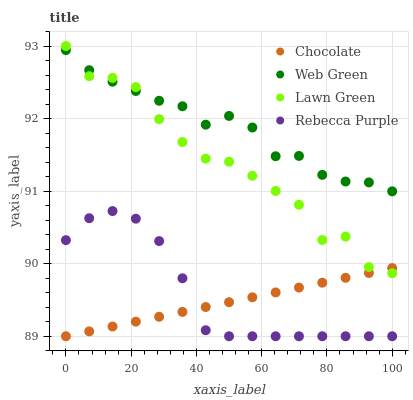Does Chocolate have the minimum area under the curve?
Answer yes or no. Yes. Does Web Green have the maximum area under the curve?
Answer yes or no. Yes. Does Rebecca Purple have the minimum area under the curve?
Answer yes or no. No. Does Rebecca Purple have the maximum area under the curve?
Answer yes or no. No. Is Chocolate the smoothest?
Answer yes or no. Yes. Is Lawn Green the roughest?
Answer yes or no. Yes. Is Rebecca Purple the smoothest?
Answer yes or no. No. Is Rebecca Purple the roughest?
Answer yes or no. No. Does Rebecca Purple have the lowest value?
Answer yes or no. Yes. Does Web Green have the lowest value?
Answer yes or no. No. Does Lawn Green have the highest value?
Answer yes or no. Yes. Does Rebecca Purple have the highest value?
Answer yes or no. No. Is Rebecca Purple less than Lawn Green?
Answer yes or no. Yes. Is Web Green greater than Rebecca Purple?
Answer yes or no. Yes. Does Web Green intersect Lawn Green?
Answer yes or no. Yes. Is Web Green less than Lawn Green?
Answer yes or no. No. Is Web Green greater than Lawn Green?
Answer yes or no. No. Does Rebecca Purple intersect Lawn Green?
Answer yes or no. No. 